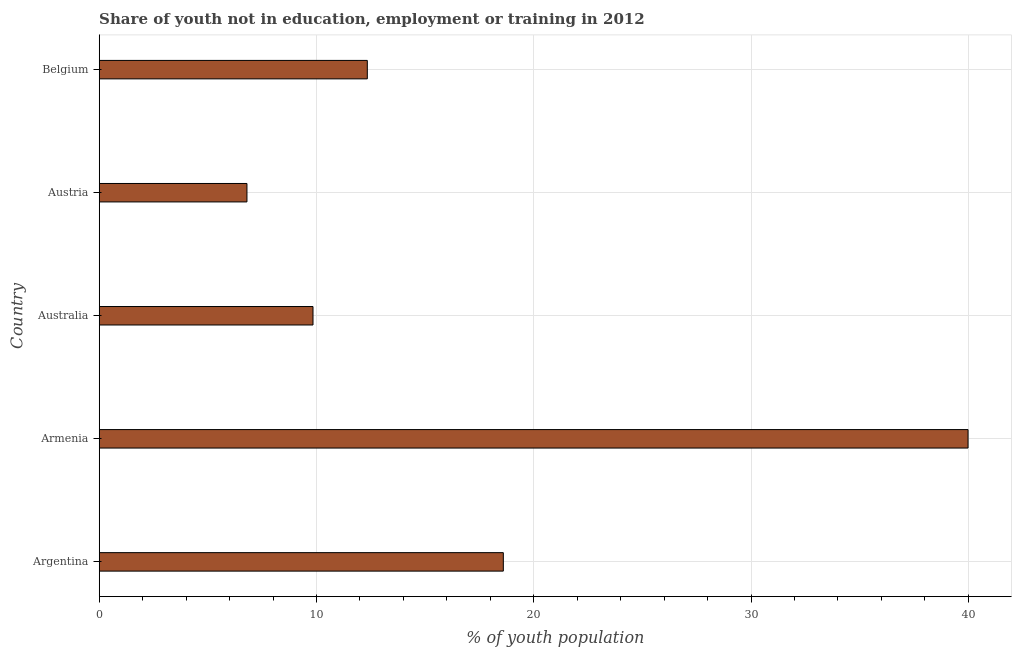Does the graph contain grids?
Your answer should be compact. Yes. What is the title of the graph?
Give a very brief answer. Share of youth not in education, employment or training in 2012. What is the label or title of the X-axis?
Your answer should be compact. % of youth population. What is the unemployed youth population in Armenia?
Give a very brief answer. 39.99. Across all countries, what is the maximum unemployed youth population?
Your answer should be compact. 39.99. Across all countries, what is the minimum unemployed youth population?
Keep it short and to the point. 6.8. In which country was the unemployed youth population maximum?
Ensure brevity in your answer.  Armenia. What is the sum of the unemployed youth population?
Give a very brief answer. 87.57. What is the difference between the unemployed youth population in Argentina and Australia?
Keep it short and to the point. 8.76. What is the average unemployed youth population per country?
Keep it short and to the point. 17.51. What is the median unemployed youth population?
Your response must be concise. 12.34. What is the ratio of the unemployed youth population in Austria to that in Belgium?
Make the answer very short. 0.55. Is the unemployed youth population in Armenia less than that in Belgium?
Ensure brevity in your answer.  No. What is the difference between the highest and the second highest unemployed youth population?
Your answer should be compact. 21.39. What is the difference between the highest and the lowest unemployed youth population?
Offer a terse response. 33.19. In how many countries, is the unemployed youth population greater than the average unemployed youth population taken over all countries?
Your response must be concise. 2. How many countries are there in the graph?
Provide a succinct answer. 5. What is the difference between two consecutive major ticks on the X-axis?
Keep it short and to the point. 10. What is the % of youth population of Argentina?
Your answer should be very brief. 18.6. What is the % of youth population of Armenia?
Give a very brief answer. 39.99. What is the % of youth population in Australia?
Provide a succinct answer. 9.84. What is the % of youth population of Austria?
Provide a succinct answer. 6.8. What is the % of youth population in Belgium?
Your answer should be compact. 12.34. What is the difference between the % of youth population in Argentina and Armenia?
Keep it short and to the point. -21.39. What is the difference between the % of youth population in Argentina and Australia?
Provide a succinct answer. 8.76. What is the difference between the % of youth population in Argentina and Austria?
Provide a short and direct response. 11.8. What is the difference between the % of youth population in Argentina and Belgium?
Offer a terse response. 6.26. What is the difference between the % of youth population in Armenia and Australia?
Give a very brief answer. 30.15. What is the difference between the % of youth population in Armenia and Austria?
Keep it short and to the point. 33.19. What is the difference between the % of youth population in Armenia and Belgium?
Keep it short and to the point. 27.65. What is the difference between the % of youth population in Australia and Austria?
Give a very brief answer. 3.04. What is the difference between the % of youth population in Austria and Belgium?
Keep it short and to the point. -5.54. What is the ratio of the % of youth population in Argentina to that in Armenia?
Offer a terse response. 0.47. What is the ratio of the % of youth population in Argentina to that in Australia?
Your answer should be compact. 1.89. What is the ratio of the % of youth population in Argentina to that in Austria?
Provide a short and direct response. 2.73. What is the ratio of the % of youth population in Argentina to that in Belgium?
Provide a succinct answer. 1.51. What is the ratio of the % of youth population in Armenia to that in Australia?
Offer a terse response. 4.06. What is the ratio of the % of youth population in Armenia to that in Austria?
Offer a terse response. 5.88. What is the ratio of the % of youth population in Armenia to that in Belgium?
Offer a very short reply. 3.24. What is the ratio of the % of youth population in Australia to that in Austria?
Make the answer very short. 1.45. What is the ratio of the % of youth population in Australia to that in Belgium?
Offer a terse response. 0.8. What is the ratio of the % of youth population in Austria to that in Belgium?
Ensure brevity in your answer.  0.55. 